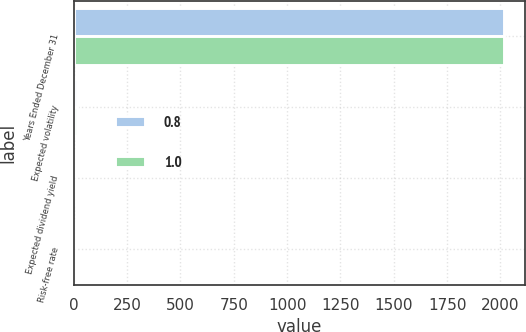Convert chart. <chart><loc_0><loc_0><loc_500><loc_500><stacked_bar_chart><ecel><fcel>Years Ended December 31<fcel>Expected volatility<fcel>Expected dividend yield<fcel>Risk-free rate<nl><fcel>0.8<fcel>2016<fcel>16.7<fcel>3.2<fcel>1<nl><fcel>1<fcel>2015<fcel>14.1<fcel>3.3<fcel>0.8<nl></chart> 